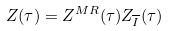<formula> <loc_0><loc_0><loc_500><loc_500>Z ( \tau ) = Z ^ { M R } ( \tau ) Z _ { \overline { I } } ( \tau )</formula> 